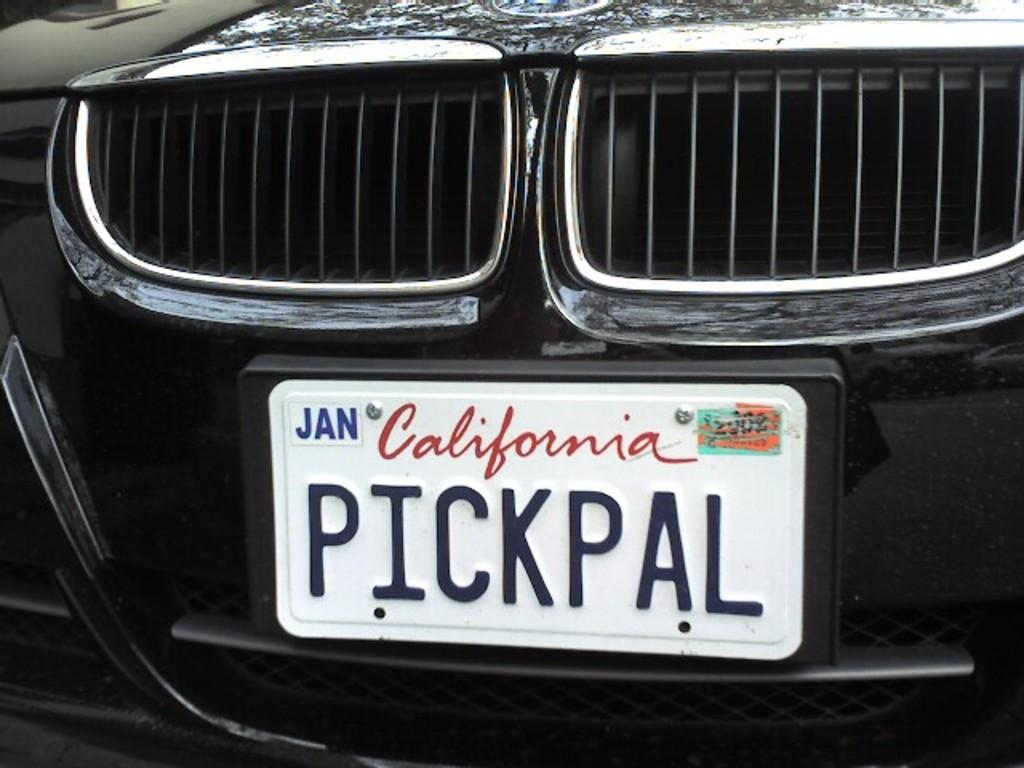What is the main subject of the image? The main subject of the image is the front part of a car. What color is the car in the image? The car is black in color. What other object can be seen in the image besides the car? There is a board in the image. What color is the board in the image? The board is white in color. Can you tell me how many people are standing next to the car in the image? There is no person present in the image; it only shows the front part of a car and a white board. What type of sign is displayed on the board in the image? There is no sign displayed on the board in the image; it is just a plain white board. 